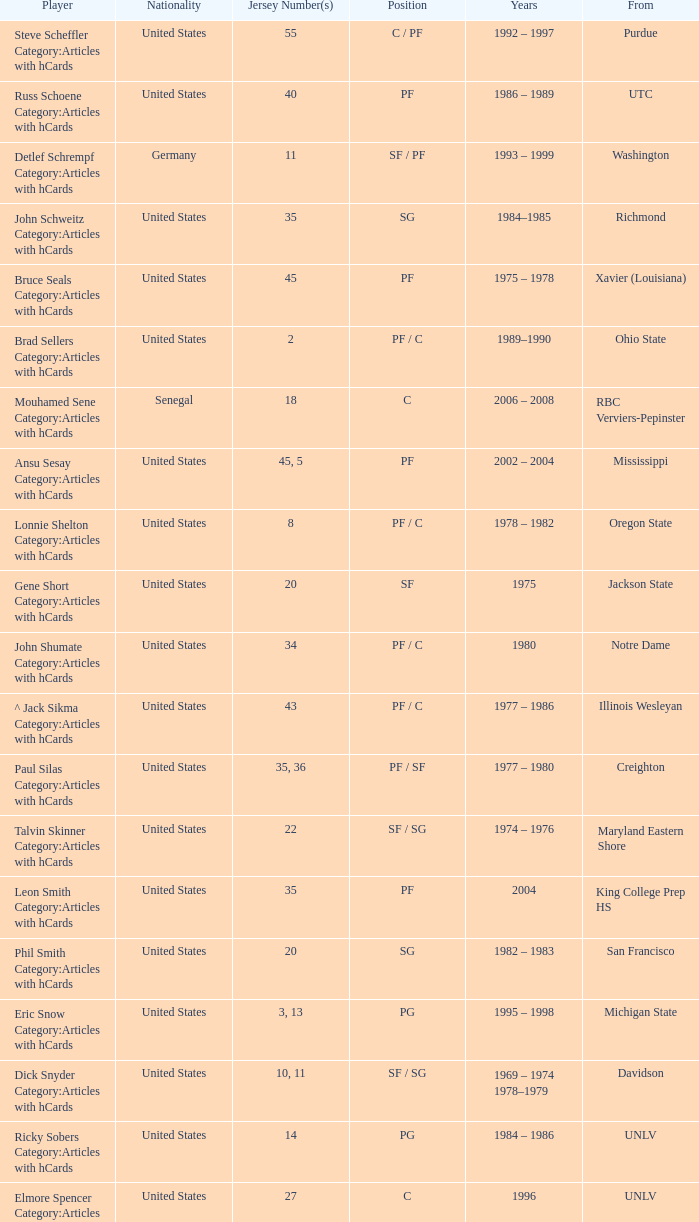Who wears the jersey number 20 and has the position of SG? Phil Smith Category:Articles with hCards, Jon Sundvold Category:Articles with hCards. 